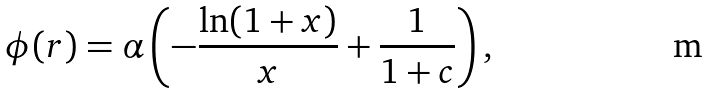<formula> <loc_0><loc_0><loc_500><loc_500>\phi ( r ) = \alpha \left ( - \frac { \ln ( 1 + x ) } { x } + \frac { 1 } { 1 + c } \right ) ,</formula> 